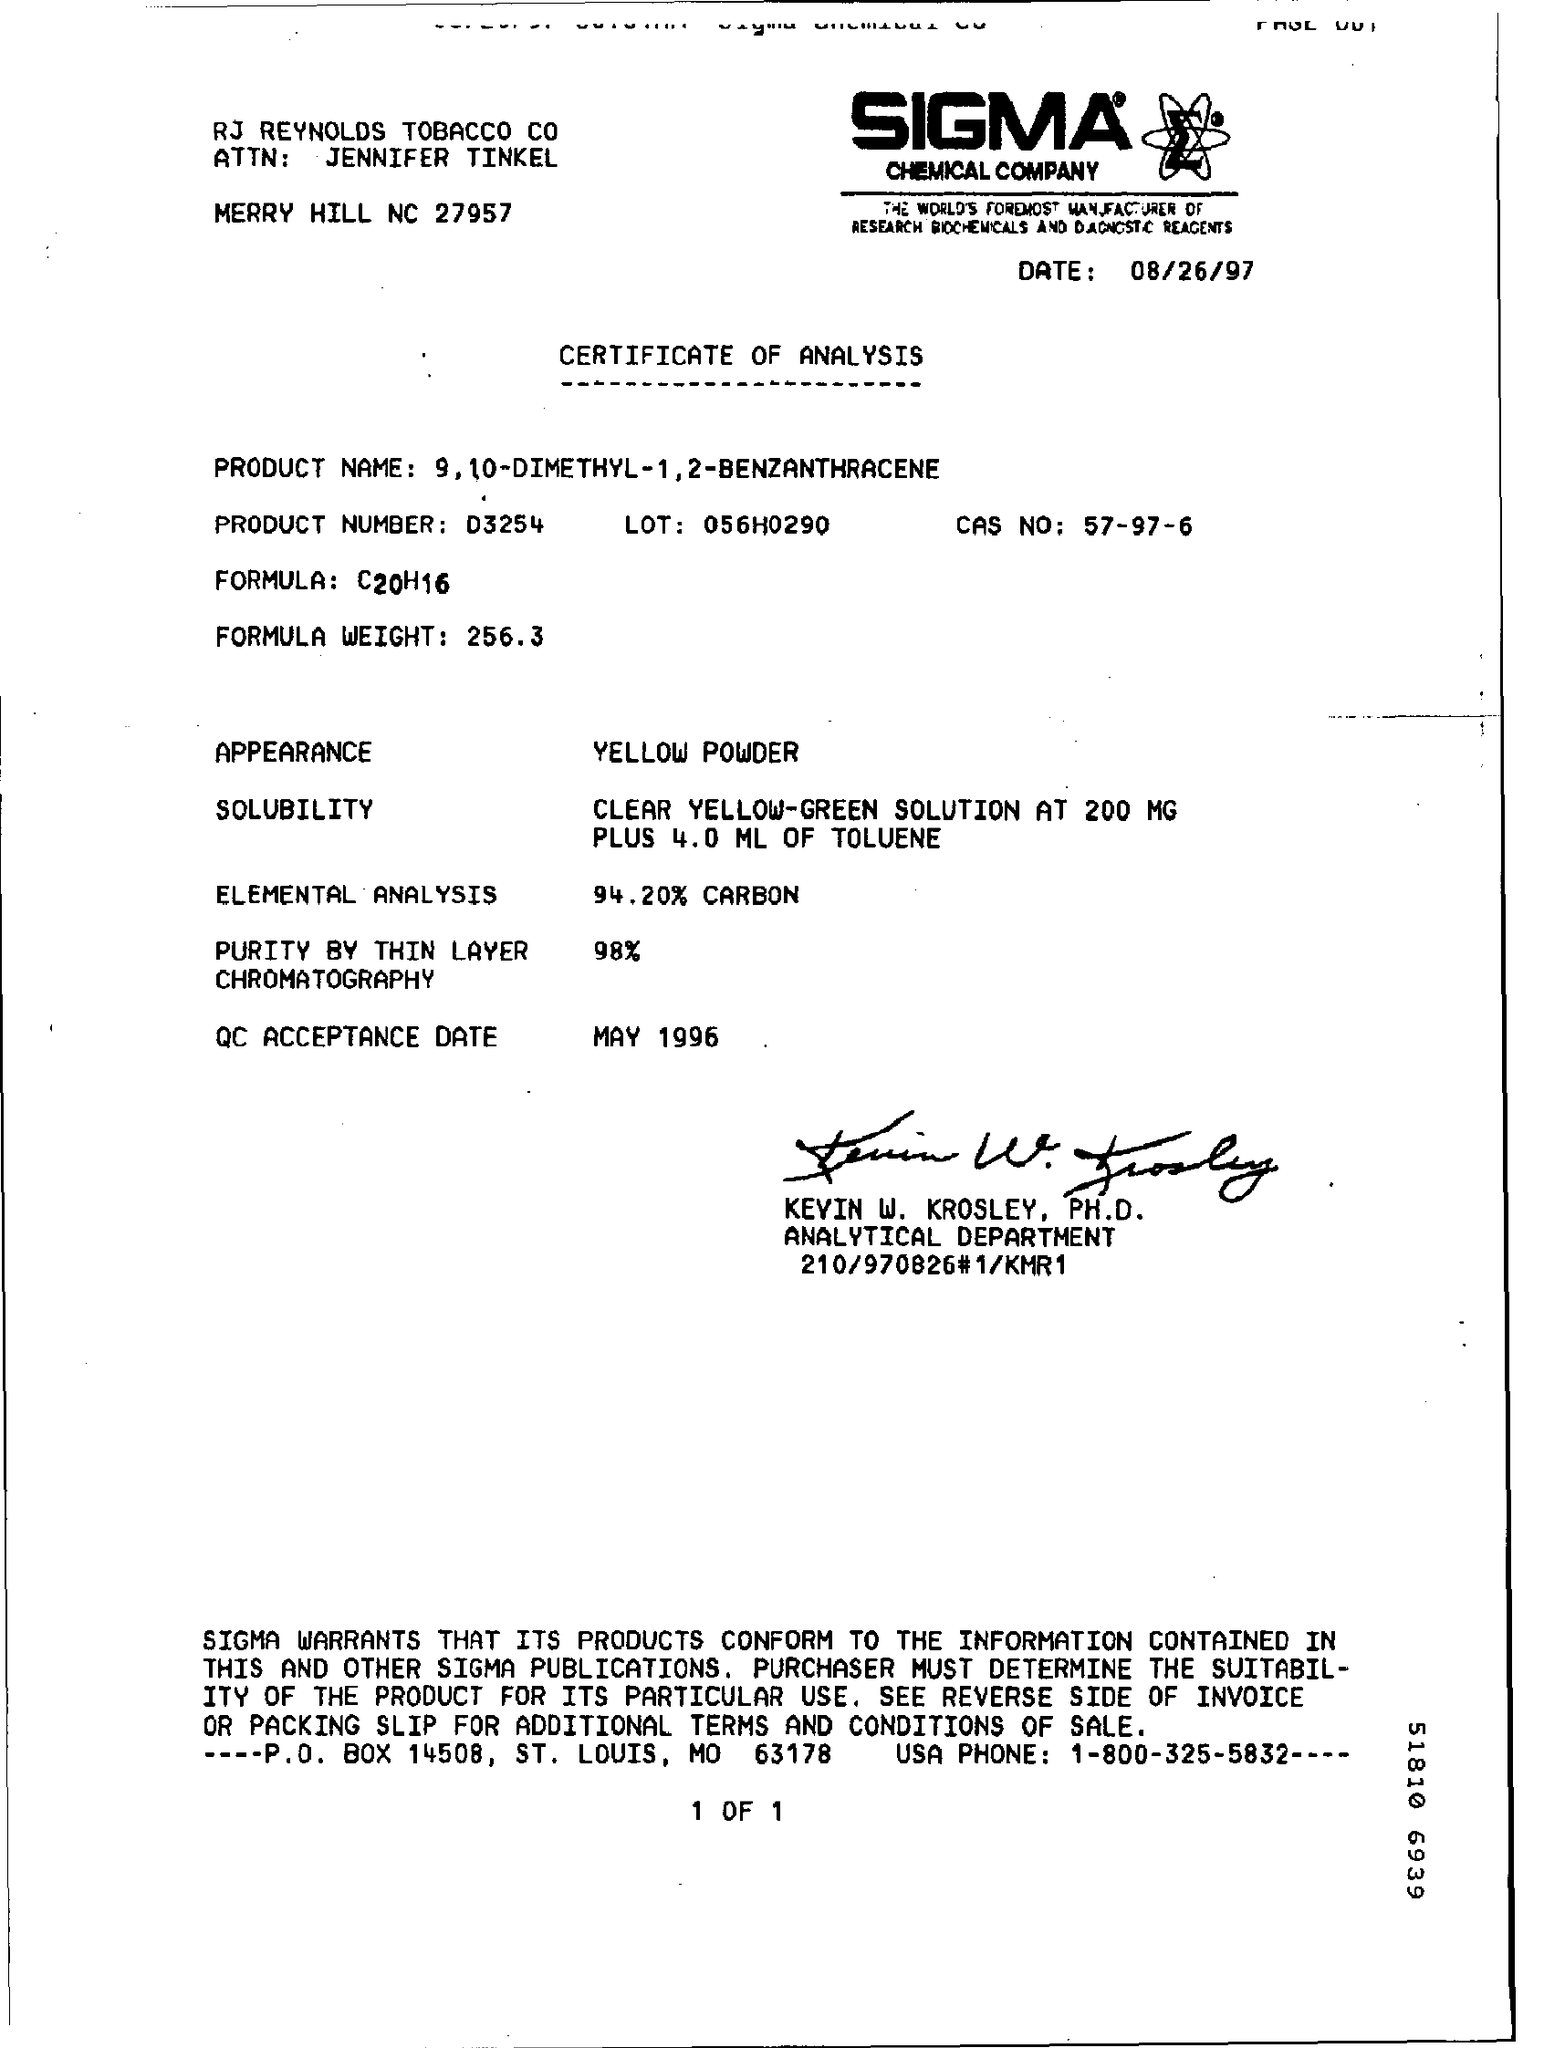What is the Date?
Your response must be concise. 08/26/97. What is the Title of the document?
Provide a succinct answer. CERTIFICATE OF ANALYSIS. What is the Product Number?
Your response must be concise. D3254. What is the Lot?
Provide a succinct answer. 056H0290. What is the CAS NO?
Give a very brief answer. 57-97-6. What is the Formula?
Keep it short and to the point. C20H16. What is the Appearance?
Your answer should be very brief. Yellow Powder. What is the QC Acceptance Date?
Ensure brevity in your answer.  May 1996. 